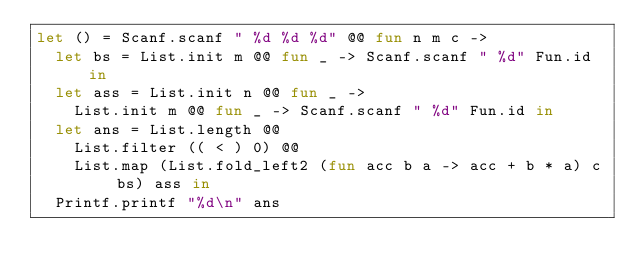Convert code to text. <code><loc_0><loc_0><loc_500><loc_500><_OCaml_>let () = Scanf.scanf " %d %d %d" @@ fun n m c ->
  let bs = List.init m @@ fun _ -> Scanf.scanf " %d" Fun.id in
  let ass = List.init n @@ fun _ ->
    List.init m @@ fun _ -> Scanf.scanf " %d" Fun.id in
  let ans = List.length @@
    List.filter (( < ) 0) @@
    List.map (List.fold_left2 (fun acc b a -> acc + b * a) c bs) ass in
  Printf.printf "%d\n" ans
</code> 